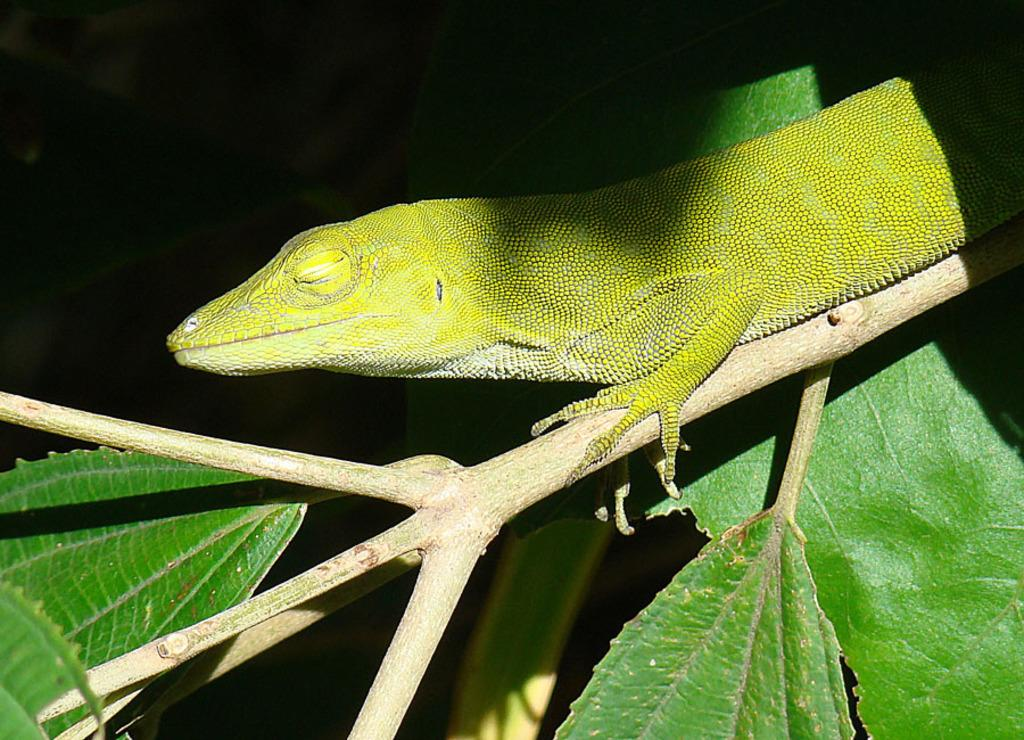What is the main subject of the image? The main subject of the image is a plant stem with leaves. Is there anything else present on the stem? Yes, there is a lizard on the stem. What color is the lizard? The lizard is green in color. What type of arch can be seen in the downtown area in the image? There is no downtown area or arch present in the image; it features a plant stem with leaves and a green lizard. 